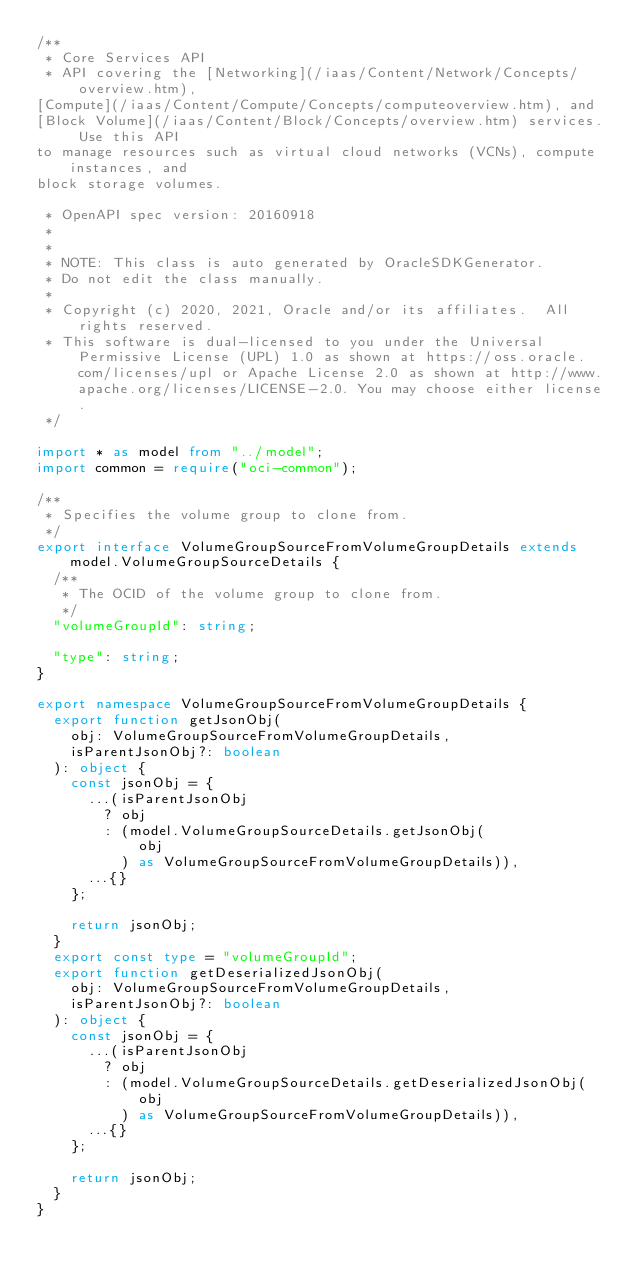Convert code to text. <code><loc_0><loc_0><loc_500><loc_500><_TypeScript_>/**
 * Core Services API
 * API covering the [Networking](/iaas/Content/Network/Concepts/overview.htm),
[Compute](/iaas/Content/Compute/Concepts/computeoverview.htm), and
[Block Volume](/iaas/Content/Block/Concepts/overview.htm) services. Use this API
to manage resources such as virtual cloud networks (VCNs), compute instances, and
block storage volumes.

 * OpenAPI spec version: 20160918
 * 
 *
 * NOTE: This class is auto generated by OracleSDKGenerator.
 * Do not edit the class manually.
 *
 * Copyright (c) 2020, 2021, Oracle and/or its affiliates.  All rights reserved.
 * This software is dual-licensed to you under the Universal Permissive License (UPL) 1.0 as shown at https://oss.oracle.com/licenses/upl or Apache License 2.0 as shown at http://www.apache.org/licenses/LICENSE-2.0. You may choose either license.
 */

import * as model from "../model";
import common = require("oci-common");

/**
 * Specifies the volume group to clone from.
 */
export interface VolumeGroupSourceFromVolumeGroupDetails extends model.VolumeGroupSourceDetails {
  /**
   * The OCID of the volume group to clone from.
   */
  "volumeGroupId": string;

  "type": string;
}

export namespace VolumeGroupSourceFromVolumeGroupDetails {
  export function getJsonObj(
    obj: VolumeGroupSourceFromVolumeGroupDetails,
    isParentJsonObj?: boolean
  ): object {
    const jsonObj = {
      ...(isParentJsonObj
        ? obj
        : (model.VolumeGroupSourceDetails.getJsonObj(
            obj
          ) as VolumeGroupSourceFromVolumeGroupDetails)),
      ...{}
    };

    return jsonObj;
  }
  export const type = "volumeGroupId";
  export function getDeserializedJsonObj(
    obj: VolumeGroupSourceFromVolumeGroupDetails,
    isParentJsonObj?: boolean
  ): object {
    const jsonObj = {
      ...(isParentJsonObj
        ? obj
        : (model.VolumeGroupSourceDetails.getDeserializedJsonObj(
            obj
          ) as VolumeGroupSourceFromVolumeGroupDetails)),
      ...{}
    };

    return jsonObj;
  }
}
</code> 